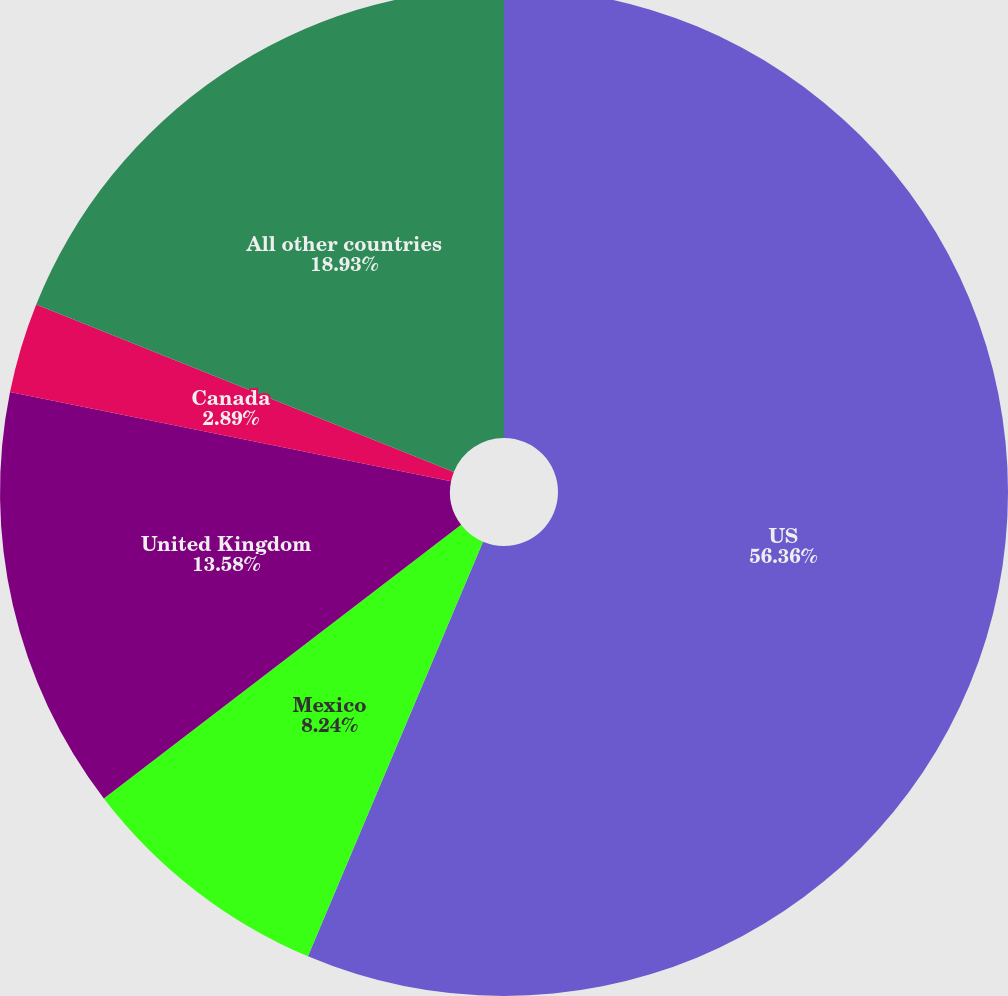Convert chart. <chart><loc_0><loc_0><loc_500><loc_500><pie_chart><fcel>US<fcel>Mexico<fcel>United Kingdom<fcel>Canada<fcel>All other countries<nl><fcel>56.36%<fcel>8.24%<fcel>13.58%<fcel>2.89%<fcel>18.93%<nl></chart> 